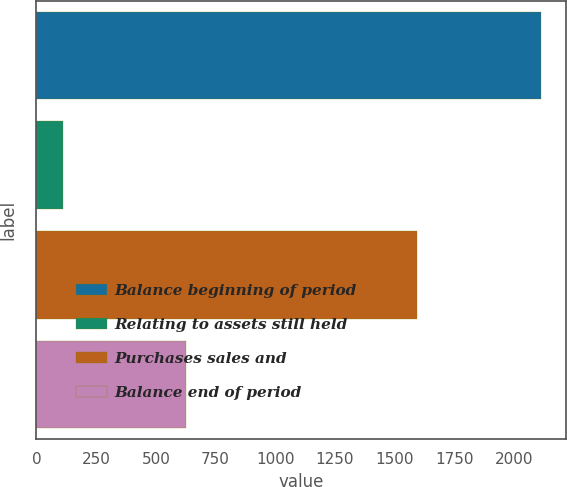<chart> <loc_0><loc_0><loc_500><loc_500><bar_chart><fcel>Balance beginning of period<fcel>Relating to assets still held<fcel>Purchases sales and<fcel>Balance end of period<nl><fcel>2111<fcel>110<fcel>1593<fcel>628<nl></chart> 